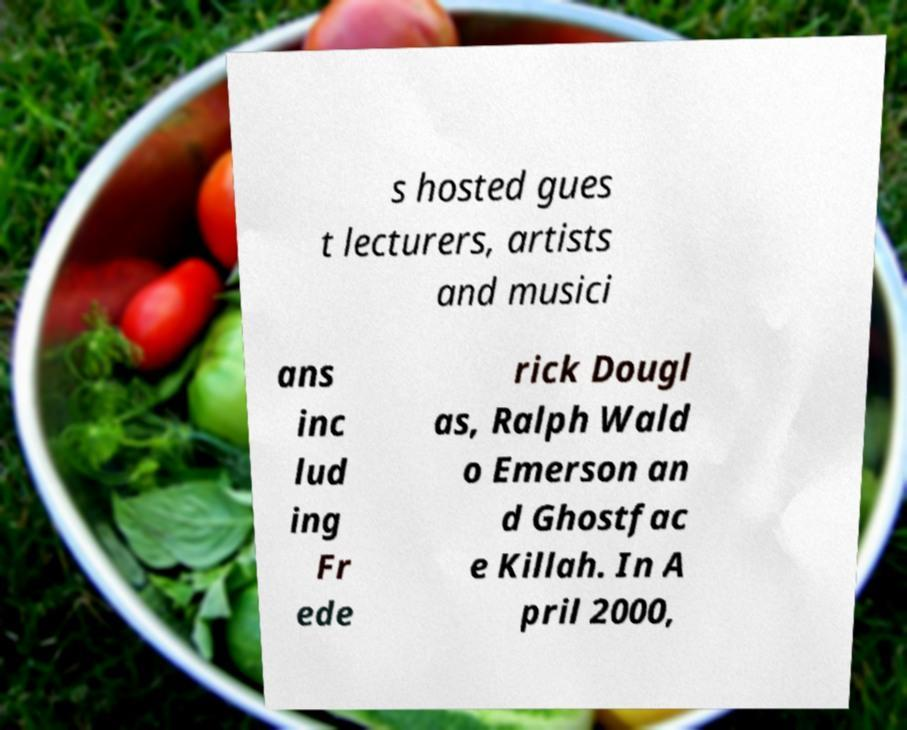There's text embedded in this image that I need extracted. Can you transcribe it verbatim? s hosted gues t lecturers, artists and musici ans inc lud ing Fr ede rick Dougl as, Ralph Wald o Emerson an d Ghostfac e Killah. In A pril 2000, 